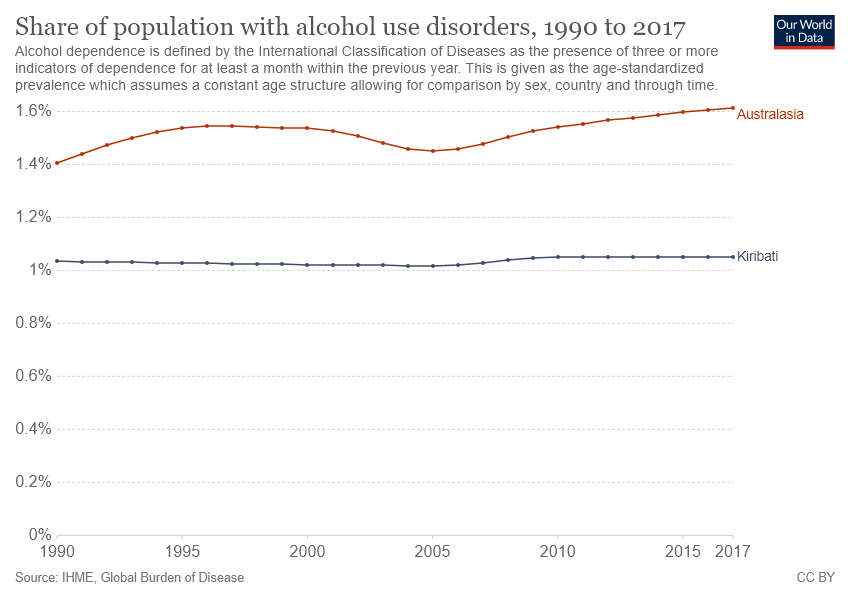Outline some significant characteristics in this image. The minimum difference between the values of Australasia and Kiribati occurred in 1990. The country with the least share of its population with alcohol use disorders is Kiribati. 